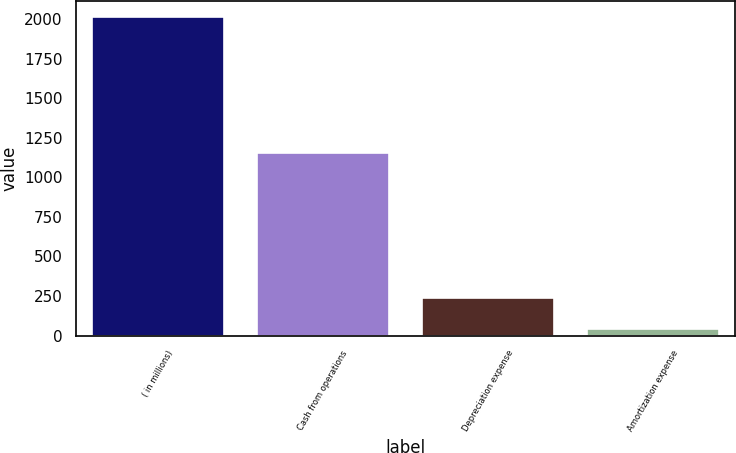Convert chart to OTSL. <chart><loc_0><loc_0><loc_500><loc_500><bar_chart><fcel>( in millions)<fcel>Cash from operations<fcel>Depreciation expense<fcel>Amortization expense<nl><fcel>2010<fcel>1151<fcel>237<fcel>40<nl></chart> 